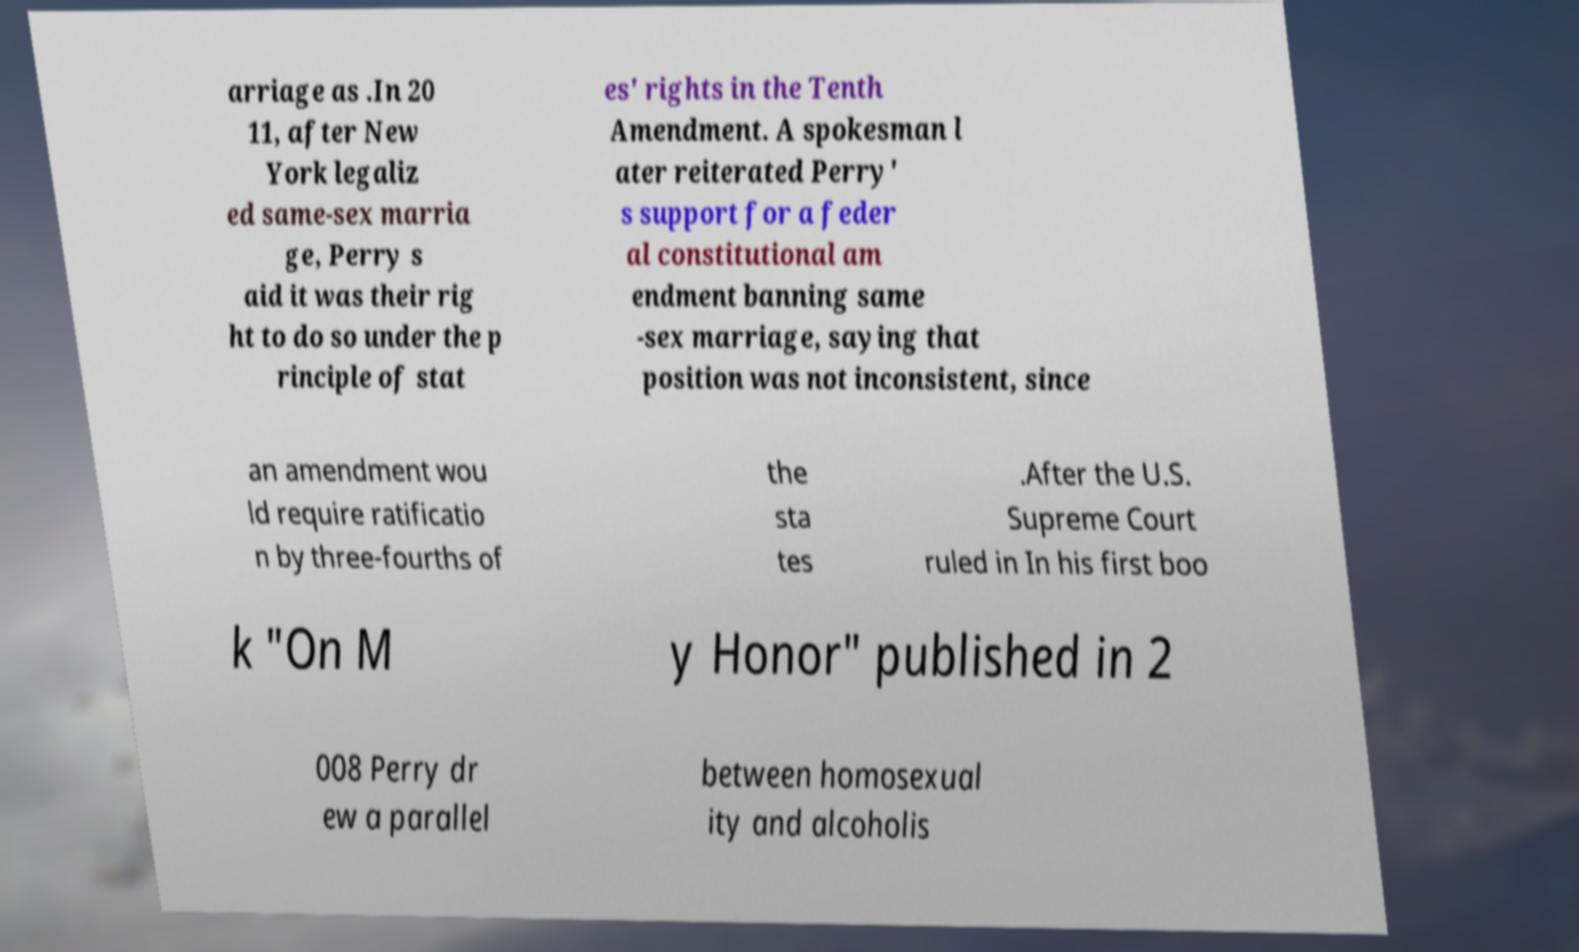Could you extract and type out the text from this image? arriage as .In 20 11, after New York legaliz ed same-sex marria ge, Perry s aid it was their rig ht to do so under the p rinciple of stat es' rights in the Tenth Amendment. A spokesman l ater reiterated Perry' s support for a feder al constitutional am endment banning same -sex marriage, saying that position was not inconsistent, since an amendment wou ld require ratificatio n by three-fourths of the sta tes .After the U.S. Supreme Court ruled in In his first boo k "On M y Honor" published in 2 008 Perry dr ew a parallel between homosexual ity and alcoholis 